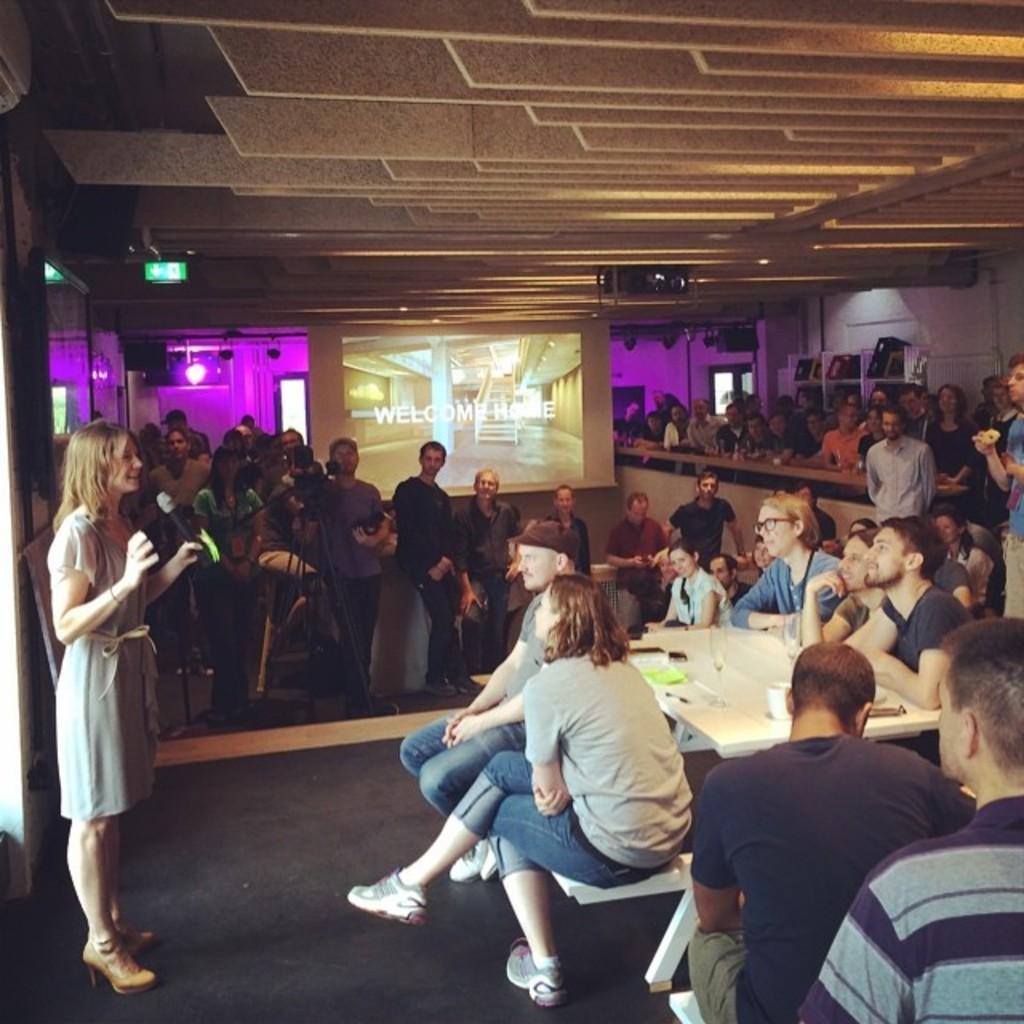Can you describe this image briefly? In this image I can see the group of people. Among them some people are sitting in front of them. On the table there is a glass and the cups. To the left one person standing and holding the mic. In the back there is a screen and the lights. 